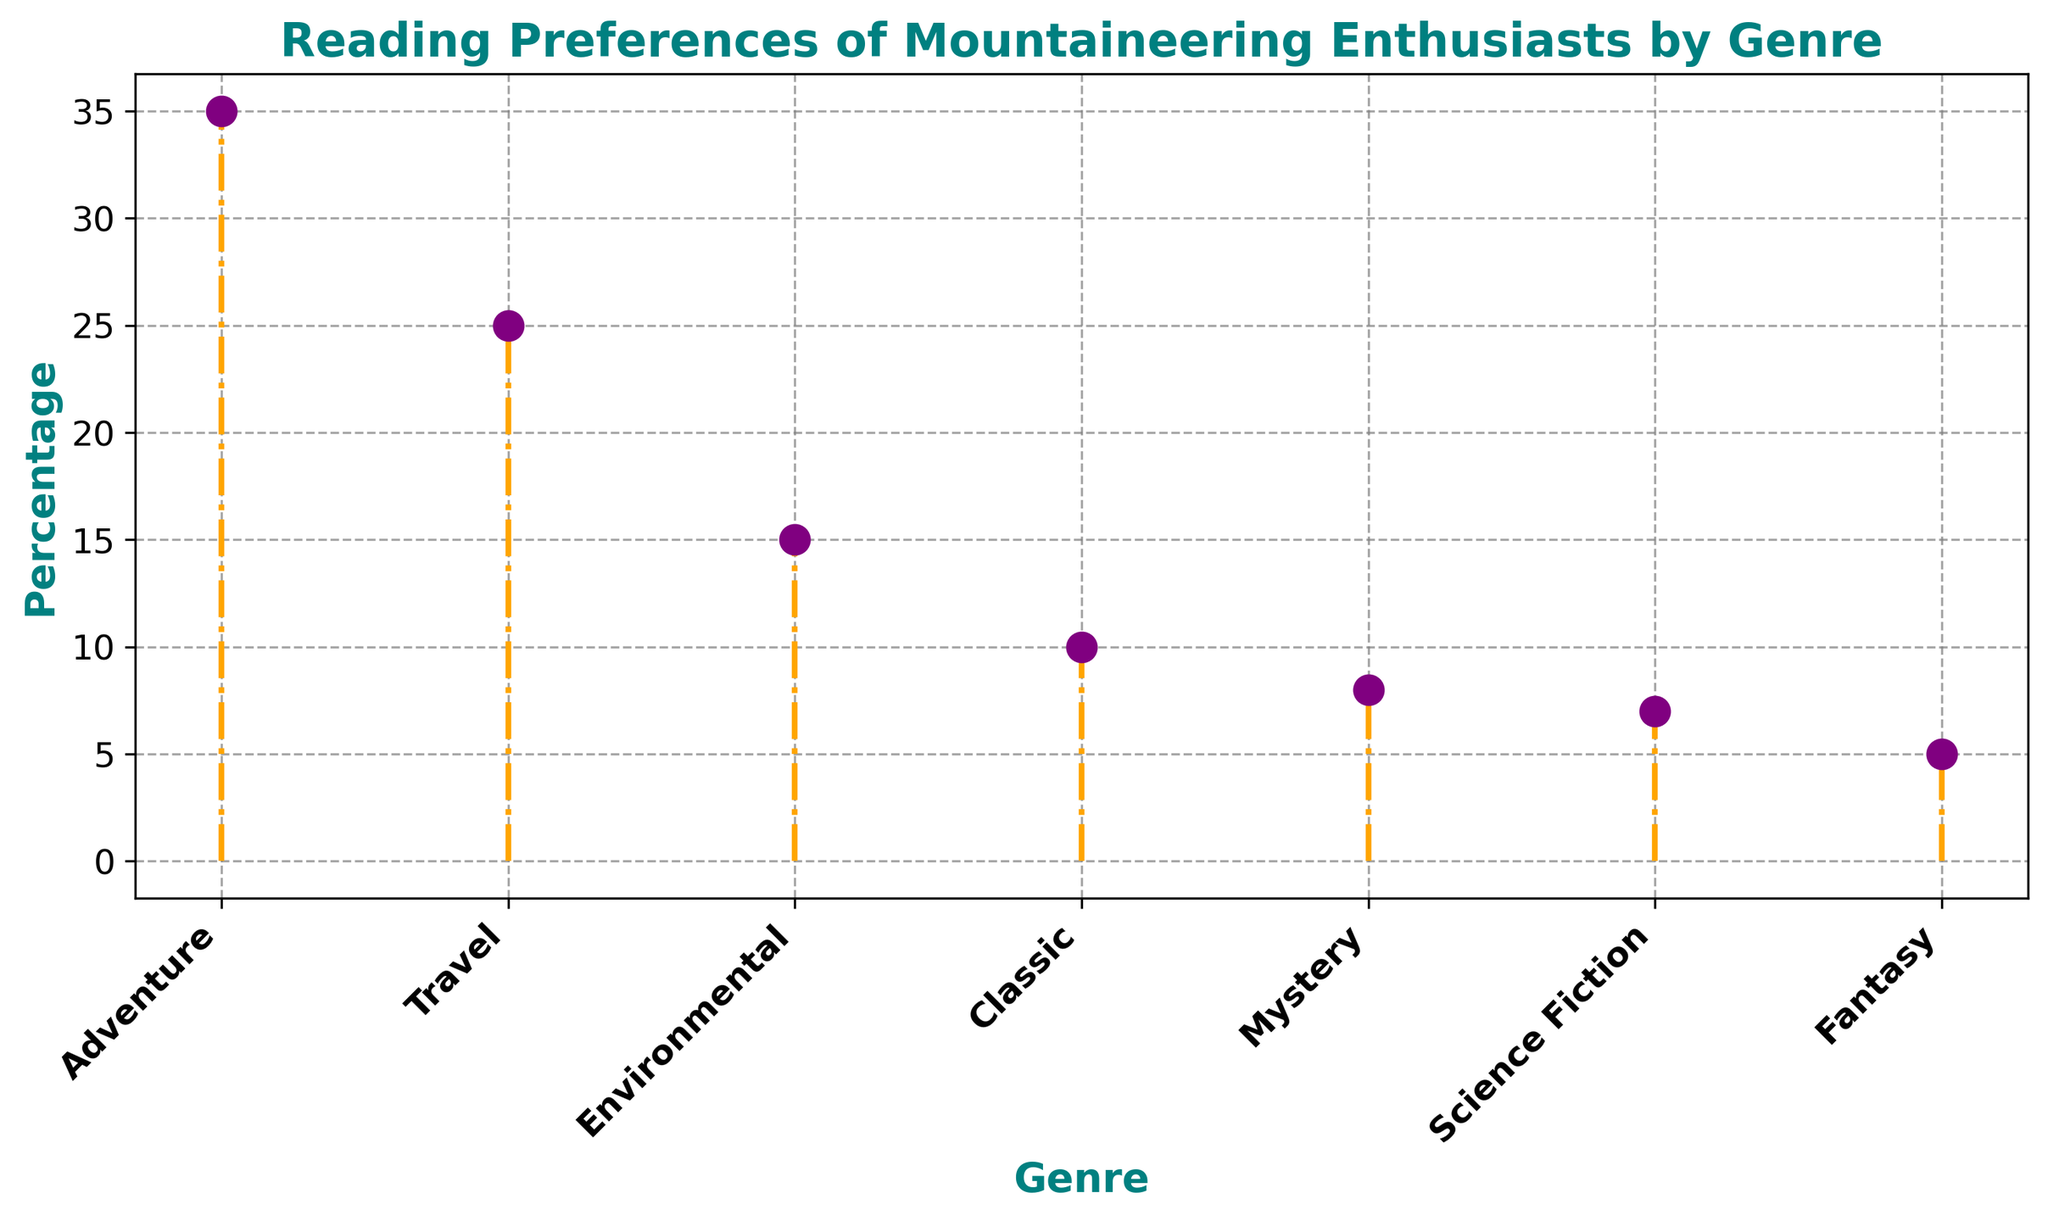What is the most popular genre among mountaineering enthusiasts? The genre with the highest percentage is the most popular. According to the figure, Adventure is at 35%, which is higher than any other genre.
Answer: Adventure How many genres have a reading preference above 20%? By visually inspecting the percentages, only Adventure (35%) and Travel (25%) are above the 20% threshold. This totals two genres.
Answer: 2 Which genre has the smallest percentage, and what is that percentage? The genre with the smallest percentage is the one where the stem plot marker is the lowest. Fantasy has the smallest percentage, at 5%.
Answer: Fantasy, 5% How does the popularity of Classic compare to that of Mystery? To compare, look at the heights of the markers for Classic and Mystery. Classic has a percentage of 10%, while Mystery has 8%. Classic is 2 percentage points higher.
Answer: Classic is more popular by 2% What is the combined percentage of Environmental and Science Fiction genres? Add the percentages of Environmental (15%) and Science Fiction (7%). The sum is 15 + 7 = 22%.
Answer: 22% Is Travel more popular than Environmental? Compare the heights of the markers for Travel (25%) and Environmental (15%). Travel is more popular by 10%.
Answer: Yes, by 10% Which genre has the second-highest reading preference? Identify the highest reading preference first (Adventure at 35%), then find the next highest. Travel is next at 25%.
Answer: Travel What is the total percentage for all genres combined? Sum up all the percentages: 35 + 25 + 15 + 10 + 8 + 7 + 5 = 105%.
Answer: 105% How does the preference for Science Fiction compare to the preference for Fantasy? Look at the percentages for Science Fiction (7%) and Fantasy (5%). Science Fiction is 2 percentage points higher.
Answer: Science Fiction is more popular by 2% Which genre readings combined exceed the Classic genre? Identify genres with a total beyond Classic's 10%. Mystery (8%) and Fantasy (5%) total 13%, which exceeds 10%.
Answer: Mystery and Fantasy together exceed 